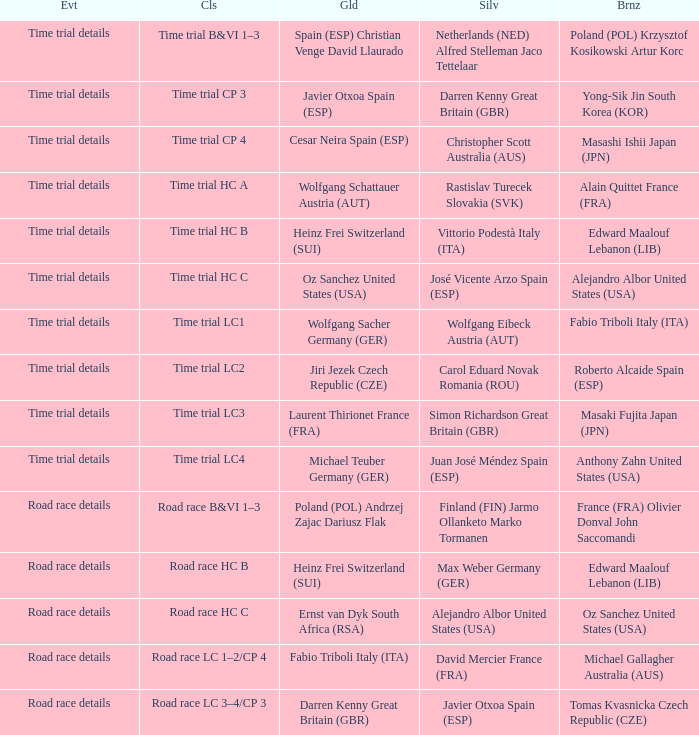Who received gold when the event is road race details and silver is max weber germany (ger)? Heinz Frei Switzerland (SUI). 